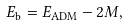<formula> <loc_0><loc_0><loc_500><loc_500>E _ { \text {b} } = E _ { \text {ADM} } - 2 M ,</formula> 